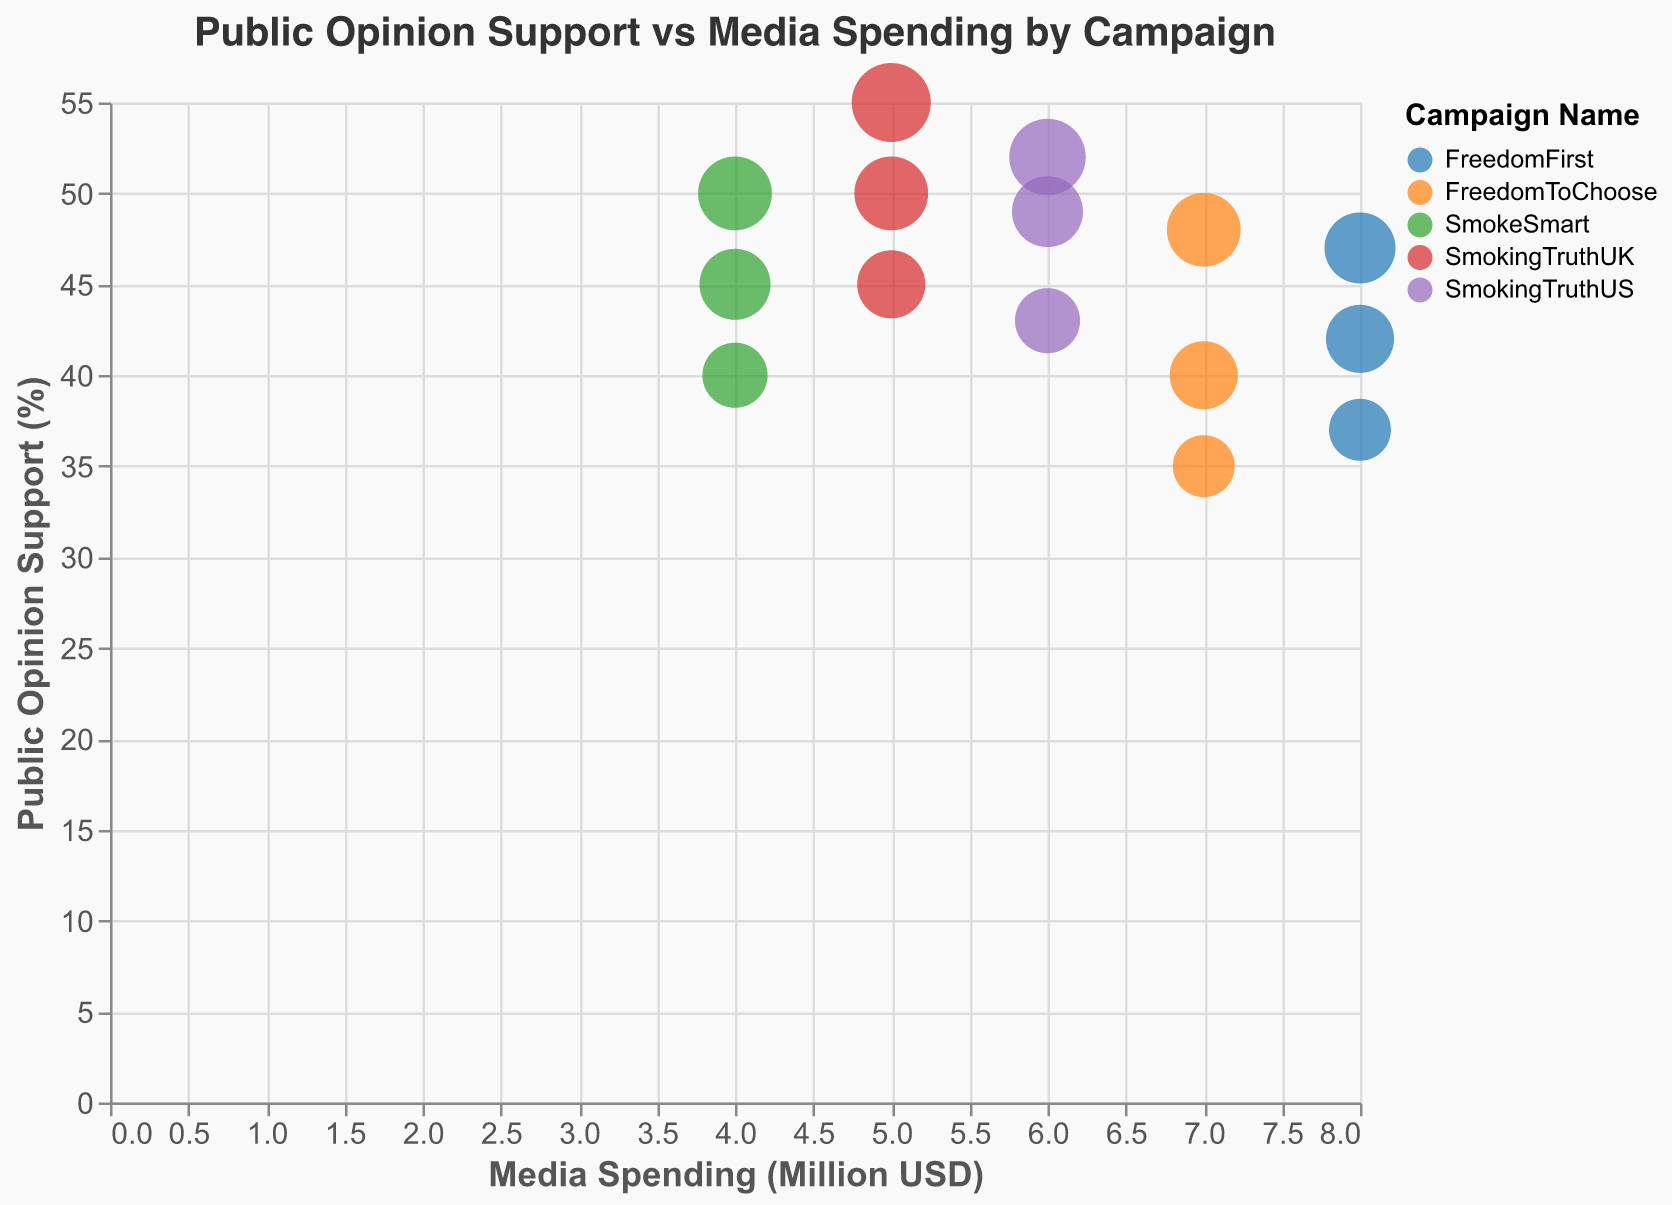What's the campaign that spends the most on media? To find the campaign with the most media spending, look at the x-axis (Media Spending in Million USD) and identify which campaign has data points farthest to the right. "FreedomFirst" has the highest media spending of 8 million USD for all recorded demographic groups.
Answer: FreedomFirst Which demographic group has the highest level of public opinion support regardless of campaign? To determine the demographic with the highest support, look at the y-axis (Public Opinion Support Percentage) and identify which demographic group has the highest value. Age 35-44 within the "SmokingTruthUK" campaign has the highest support at 55%.
Answer: Age 35-44 (55%) Among the campaigns that spend 5 million USD, which has the largest bubble size? Look for data points where Media Spending is 5 million USD (x-axis) and compare their bubble sizes. Within the SmokingTruthUK campaign, the Age 35-44 demographic group has a bubble size of 14, the largest at 5 million USD spending.
Answer: SmokingTruthUK, Age 35-44 Does more media spending generally correlate with higher public opinion support? Observe the overall trend by comparing the x-axis (media spending) and the y-axis (public opinion support). There is no clear upward trend indicating that higher spending consistently leads to higher public opinion support across campaigns.
Answer: No clear correlation Compare public opinion support between "FreedomToChoose" and "SmokingTruthUS" campaigns for the Age 25-34 demographic. Which has higher support, and by how much? Identify the public opinion support percentages for each campaign in the Age 25-34 group and calculate the difference. "FreedomToChoose" has 40% support, while "SmokingTruthUS" has 49% support. The difference is 49% - 40% = 9%.
Answer: SmokingTruthUS by 9% What is the average public opinion support for the "SmokingTruthUK" campaign? To find the average, sum the public opinion support percentages for each demographic group under "SmokingTruthUK" and divide by the number of groups. (45 + 50 + 55) / 3 = 50%.
Answer: 50% Which campaign has the smallest bubble size for the Age 18-24 demographic group? Look at the bubbles for the Age 18-24 demographic and compare the sizes. The smallest bubble size in this group is 8 for the "FreedomToChoose" and "FreedomFirst" campaigns.
Answer: FreedomToChoose and FreedomFirst For the same level of media spending, which campaign shows the highest variation in public opinion support? Compare campaigns with the same media spending level and look for the one with the largest range in y-axis values. The "FreedomFirst" campaign, spending 8 million USD, shows a variation from 37% to 47%, 10 percentage points.
Answer: FreedomFirst Which campaign-demographic combination has the lowest public opinion support? Identify the point with the lowest y-axis value. The "FreedomToChoose" campaign for the Age 18-24 demographic has the lowest public opinion support at 35%.
Answer: FreedomToChoose, Age 18-24 